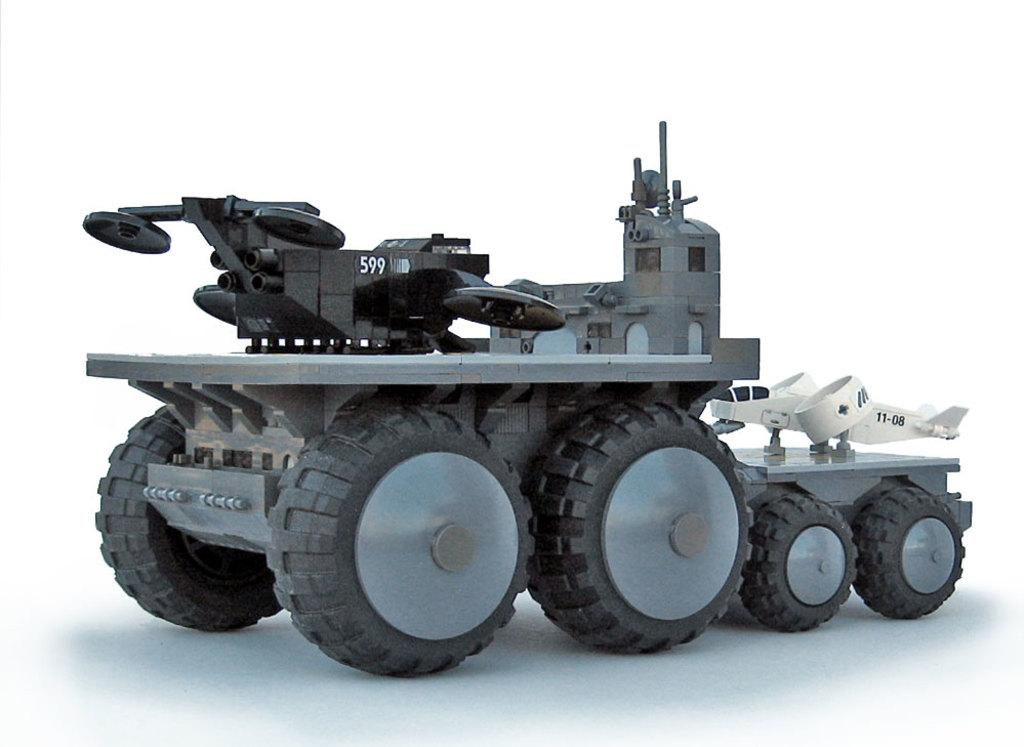What is the main subject of the image? There is a vehicle in the image. What can be seen in the background of the image? The background of the image is white. What type of calculator is visible on the side of the vehicle in the image? There is no calculator visible on the side of the vehicle in the image. 